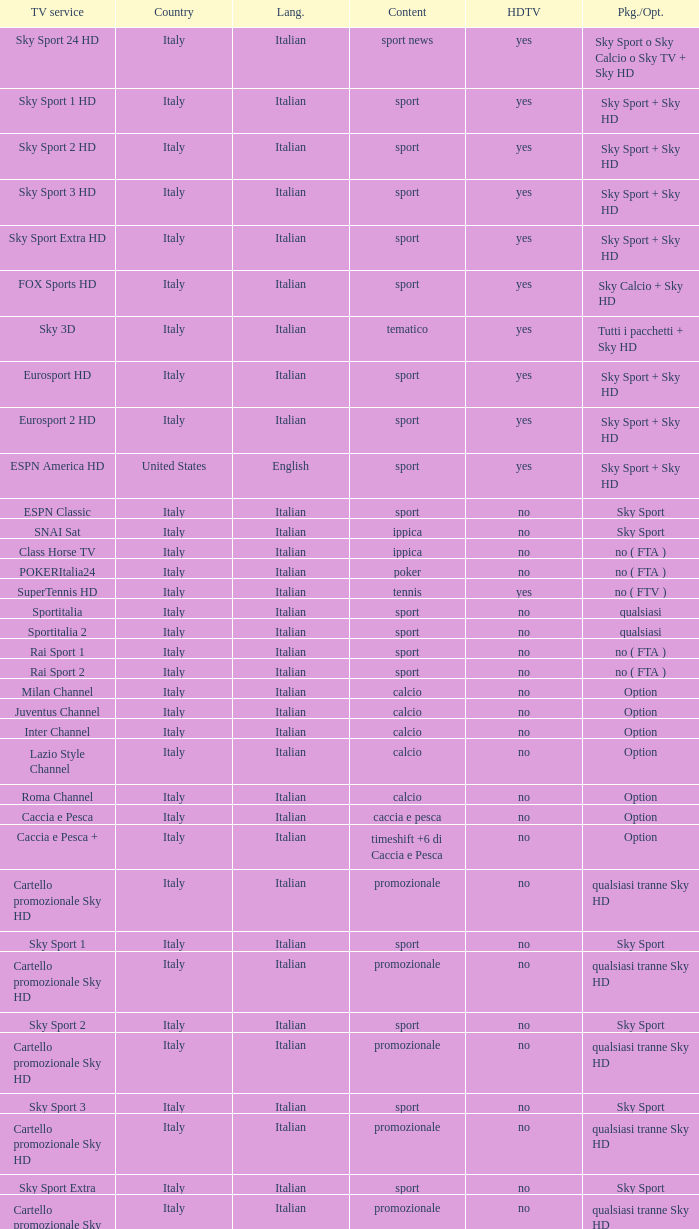Could you parse the entire table? {'header': ['TV service', 'Country', 'Lang.', 'Content', 'HDTV', 'Pkg./Opt.'], 'rows': [['Sky Sport 24 HD', 'Italy', 'Italian', 'sport news', 'yes', 'Sky Sport o Sky Calcio o Sky TV + Sky HD'], ['Sky Sport 1 HD', 'Italy', 'Italian', 'sport', 'yes', 'Sky Sport + Sky HD'], ['Sky Sport 2 HD', 'Italy', 'Italian', 'sport', 'yes', 'Sky Sport + Sky HD'], ['Sky Sport 3 HD', 'Italy', 'Italian', 'sport', 'yes', 'Sky Sport + Sky HD'], ['Sky Sport Extra HD', 'Italy', 'Italian', 'sport', 'yes', 'Sky Sport + Sky HD'], ['FOX Sports HD', 'Italy', 'Italian', 'sport', 'yes', 'Sky Calcio + Sky HD'], ['Sky 3D', 'Italy', 'Italian', 'tematico', 'yes', 'Tutti i pacchetti + Sky HD'], ['Eurosport HD', 'Italy', 'Italian', 'sport', 'yes', 'Sky Sport + Sky HD'], ['Eurosport 2 HD', 'Italy', 'Italian', 'sport', 'yes', 'Sky Sport + Sky HD'], ['ESPN America HD', 'United States', 'English', 'sport', 'yes', 'Sky Sport + Sky HD'], ['ESPN Classic', 'Italy', 'Italian', 'sport', 'no', 'Sky Sport'], ['SNAI Sat', 'Italy', 'Italian', 'ippica', 'no', 'Sky Sport'], ['Class Horse TV', 'Italy', 'Italian', 'ippica', 'no', 'no ( FTA )'], ['POKERItalia24', 'Italy', 'Italian', 'poker', 'no', 'no ( FTA )'], ['SuperTennis HD', 'Italy', 'Italian', 'tennis', 'yes', 'no ( FTV )'], ['Sportitalia', 'Italy', 'Italian', 'sport', 'no', 'qualsiasi'], ['Sportitalia 2', 'Italy', 'Italian', 'sport', 'no', 'qualsiasi'], ['Rai Sport 1', 'Italy', 'Italian', 'sport', 'no', 'no ( FTA )'], ['Rai Sport 2', 'Italy', 'Italian', 'sport', 'no', 'no ( FTA )'], ['Milan Channel', 'Italy', 'Italian', 'calcio', 'no', 'Option'], ['Juventus Channel', 'Italy', 'Italian', 'calcio', 'no', 'Option'], ['Inter Channel', 'Italy', 'Italian', 'calcio', 'no', 'Option'], ['Lazio Style Channel', 'Italy', 'Italian', 'calcio', 'no', 'Option'], ['Roma Channel', 'Italy', 'Italian', 'calcio', 'no', 'Option'], ['Caccia e Pesca', 'Italy', 'Italian', 'caccia e pesca', 'no', 'Option'], ['Caccia e Pesca +', 'Italy', 'Italian', 'timeshift +6 di Caccia e Pesca', 'no', 'Option'], ['Cartello promozionale Sky HD', 'Italy', 'Italian', 'promozionale', 'no', 'qualsiasi tranne Sky HD'], ['Sky Sport 1', 'Italy', 'Italian', 'sport', 'no', 'Sky Sport'], ['Cartello promozionale Sky HD', 'Italy', 'Italian', 'promozionale', 'no', 'qualsiasi tranne Sky HD'], ['Sky Sport 2', 'Italy', 'Italian', 'sport', 'no', 'Sky Sport'], ['Cartello promozionale Sky HD', 'Italy', 'Italian', 'promozionale', 'no', 'qualsiasi tranne Sky HD'], ['Sky Sport 3', 'Italy', 'Italian', 'sport', 'no', 'Sky Sport'], ['Cartello promozionale Sky HD', 'Italy', 'Italian', 'promozionale', 'no', 'qualsiasi tranne Sky HD'], ['Sky Sport Extra', 'Italy', 'Italian', 'sport', 'no', 'Sky Sport'], ['Cartello promozionale Sky HD', 'Italy', 'Italian', 'promozionale', 'no', 'qualsiasi tranne Sky HD'], ['Sky Supercalcio', 'Italy', 'Italian', 'calcio', 'no', 'Sky Calcio'], ['Cartello promozionale Sky HD', 'Italy', 'Italian', 'promozionale', 'no', 'qualsiasi tranne Sky HD'], ['Eurosport', 'Italy', 'Italian', 'sport', 'no', 'Sky Sport'], ['Eurosport 2', 'Italy', 'Italian', 'sport', 'no', 'Sky Sport'], ['ESPN America', 'Italy', 'Italian', 'sport', 'no', 'Sky Sport']]} What is Television Service, when Content is Calcio, and when Package/Option is Option? Milan Channel, Juventus Channel, Inter Channel, Lazio Style Channel, Roma Channel. 